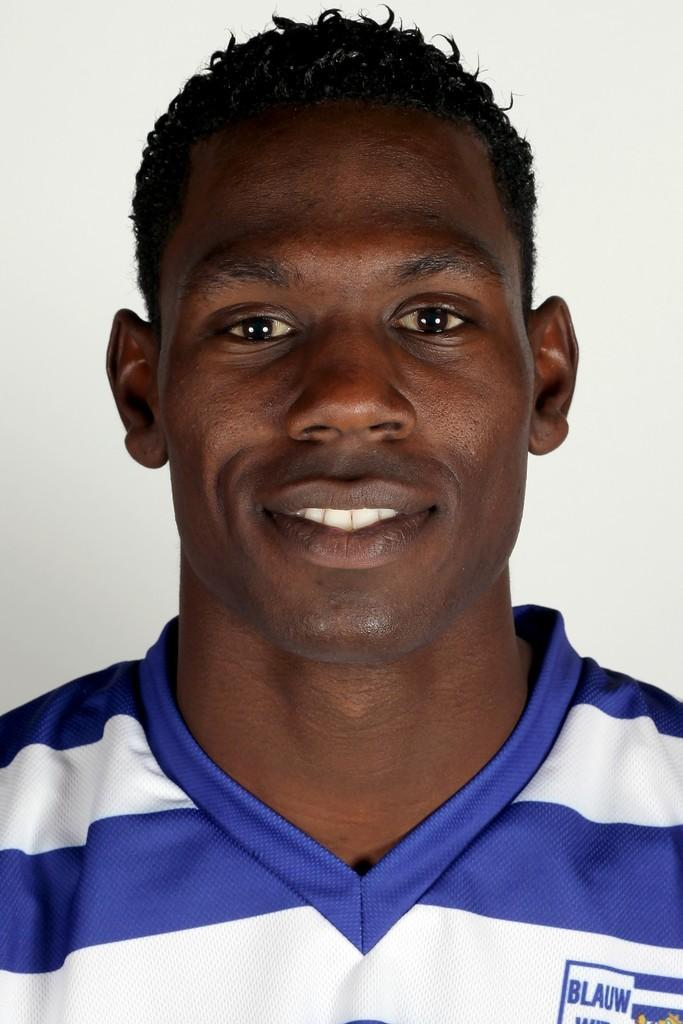<image>
Provide a brief description of the given image. Blue and white jersey with a blue lines with BLAUW written on the left side of the jersey. 